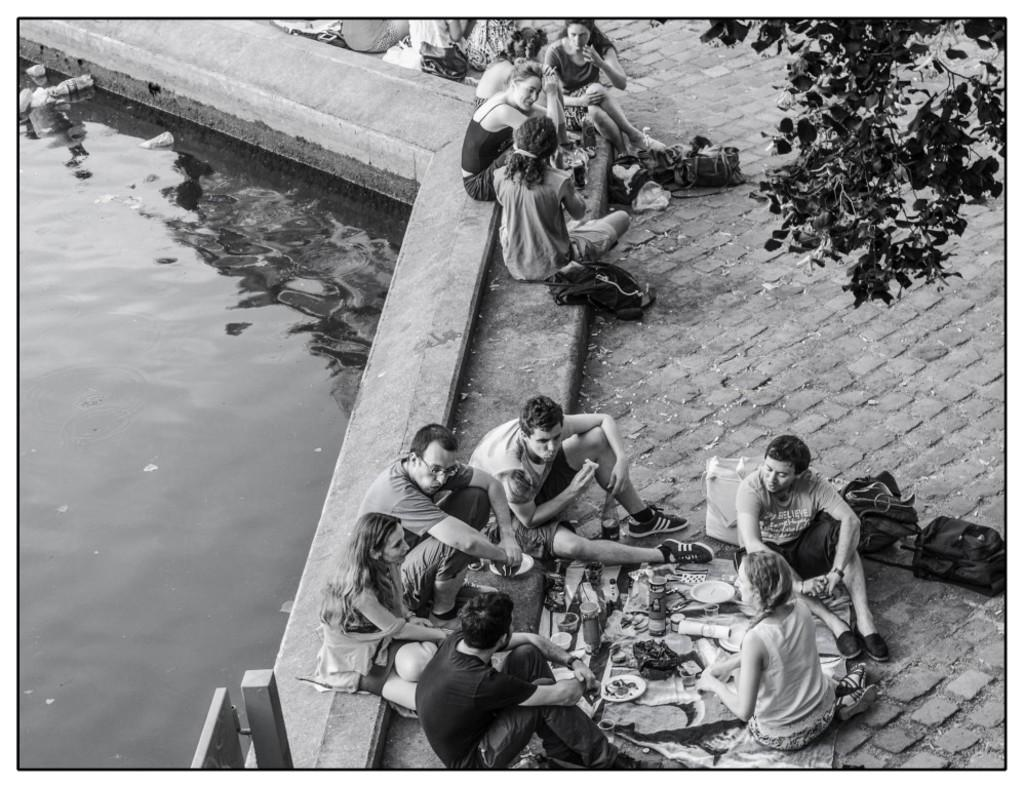What is the primary element visible in the image? There is water in the image. What type of natural element can be seen in the image? There is a tree in the image. What man-made object is present in the image? There is a pole in the image. What items are present that might be used for carrying or storing things? There are bags and bottles in the image. What objects might be used for serving or eating food? There are plates in the image. What can be seen in the image that might be used for various purposes? There are objects in the image. What are the people in the image doing? There is a group of people sitting on the ground in the image. What type of neck can be seen in the image? There is no neck visible in the image. What type of sand can be seen in the image? There is no sand visible in the image. 